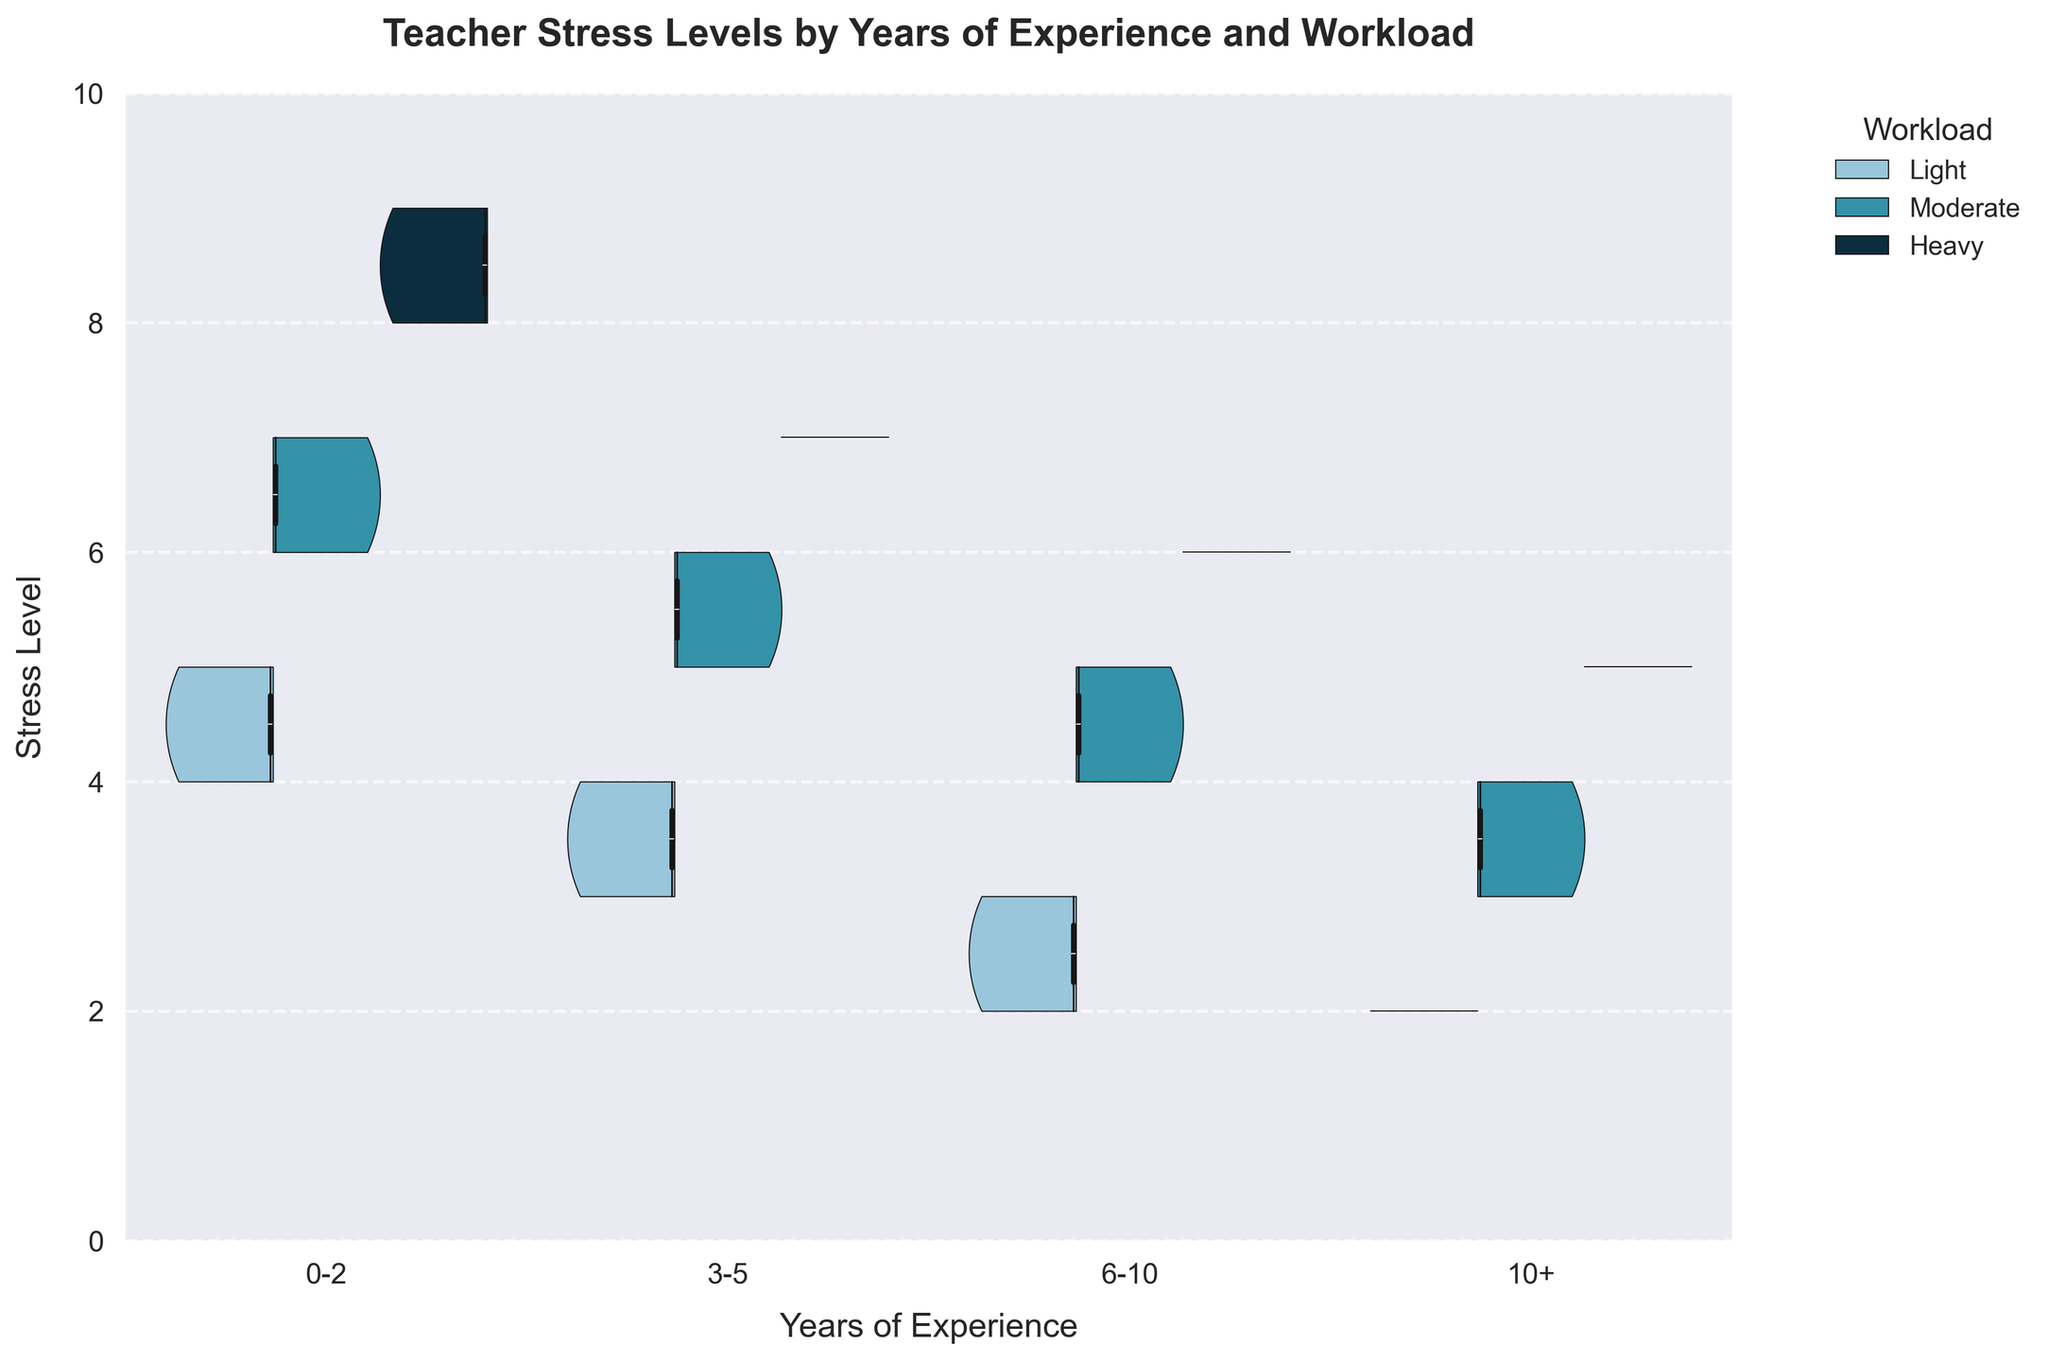How is the title of the plot worded? The title is found at the top of the plot and simply describes what the plot represents regarding teacher stress levels, years of experience, and workload.
Answer: Teacher Stress Levels by Years of Experience and Workload What are the axes labels in the plot? The x-axis label indicates the grouping by years of experience, and the y-axis label shows the measured stress levels of teachers.
Answer: x-axis: Years of Experience, y-axis: Stress Level What do the colors in the plot represent? The legend indicates that the colors correspond to different levels of workload: Light (light blue), Moderate (medium blue), and Heavy (dark blue).
Answer: Light, Moderate, Heavy What's the general trend of stress levels among teachers with over 10 years of experience? By observing the violin plots for teachers with over 10 years of experience, we see that the distributions are mainly low to moderate across all workloads.
Answer: Generally low to moderate Which workload level generally has the highest stress levels across all experience groups? By looking at the violin plots and focusing on the upper ranges of the distributions, the 'Heavy' workload consistently shows the highest stress levels across all groups.
Answer: Heavy How do median stress levels compare for teachers with 0-2 years of experience and heavy workload versus those with 6-10 years of experience and light workload? The box plot inside the violins shows that for the 'Heavy' workload and 0-2 years of experience, the median is around 8. For the 'Light' workload and 6-10 years of experience, the median is around 2.
Answer: 8 vs 2 What is the distribution shape for stress levels among teachers with 3-5 years of experience and moderate workload? The violin plot for this group can be observed to have a more symmetrical shape, indicating a balanced distribution of stress levels with a moderate clustering around the median of 5-6.
Answer: Symmetrical around median 5-6 Which experience group shows the widest distribution in stress levels for heavy workloads? By examining the width of the violins, the 0-2 years of experience group shows the widest distribution, indicating more variability in stress levels under heavy workload.
Answer: 0-2 years What’s the approximate range of stress levels for teachers with 10+ years of experience under moderate workload? By referring to the range of the violin plot, we see that stress levels for this group range from 3 to 4.
Answer: 3 to 4 In which experience group does the light workload category appear to cluster mostly at lower stress levels? Observing the light workload category violin plots, the 10+ years of experience group has stress levels clustering around values 2 with fewer outliers.
Answer: 10+ years 